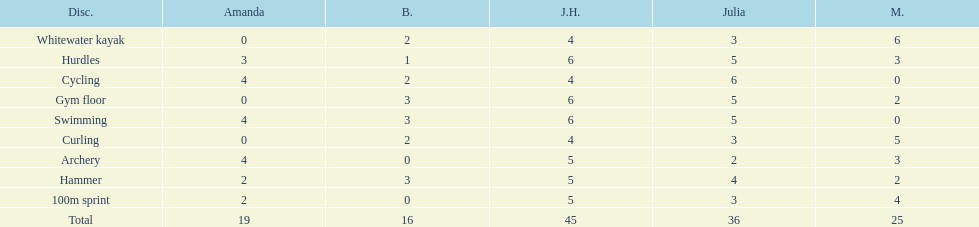What other girl besides amanda also had a 4 in cycling? Javine H. 